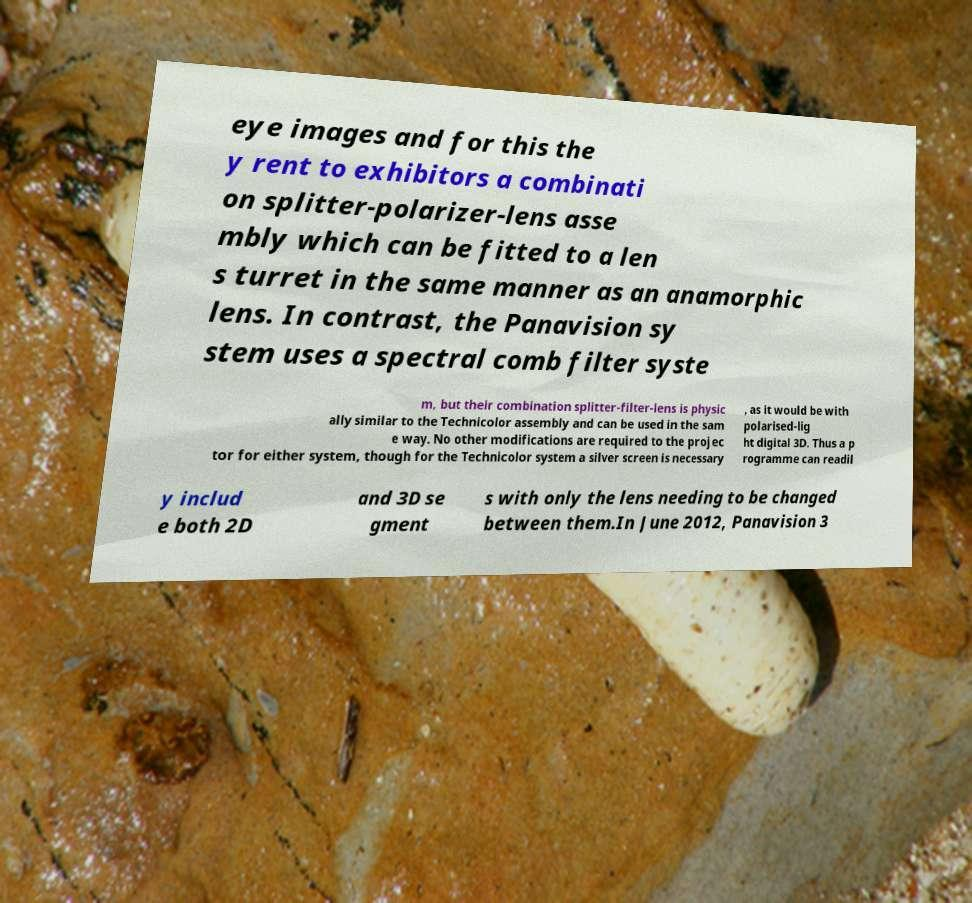I need the written content from this picture converted into text. Can you do that? eye images and for this the y rent to exhibitors a combinati on splitter-polarizer-lens asse mbly which can be fitted to a len s turret in the same manner as an anamorphic lens. In contrast, the Panavision sy stem uses a spectral comb filter syste m, but their combination splitter-filter-lens is physic ally similar to the Technicolor assembly and can be used in the sam e way. No other modifications are required to the projec tor for either system, though for the Technicolor system a silver screen is necessary , as it would be with polarised-lig ht digital 3D. Thus a p rogramme can readil y includ e both 2D and 3D se gment s with only the lens needing to be changed between them.In June 2012, Panavision 3 